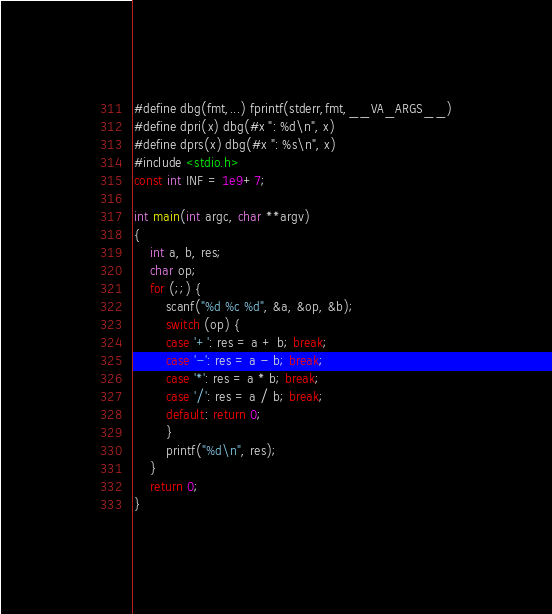<code> <loc_0><loc_0><loc_500><loc_500><_C_>#define dbg(fmt,...) fprintf(stderr,fmt,__VA_ARGS__)
#define dpri(x) dbg(#x ": %d\n", x)
#define dprs(x) dbg(#x ": %s\n", x)
#include <stdio.h>
const int INF = 1e9+7;

int main(int argc, char **argv)
{
	int a, b, res;
	char op;
	for (;;) {
		scanf("%d %c %d", &a, &op, &b);
		switch (op) {
		case '+': res = a + b; break;
		case '-': res = a - b; break;
		case '*': res = a * b; break;
		case '/': res = a / b; break;
		default: return 0;
		}
		printf("%d\n", res);
	}
	return 0;
}</code> 